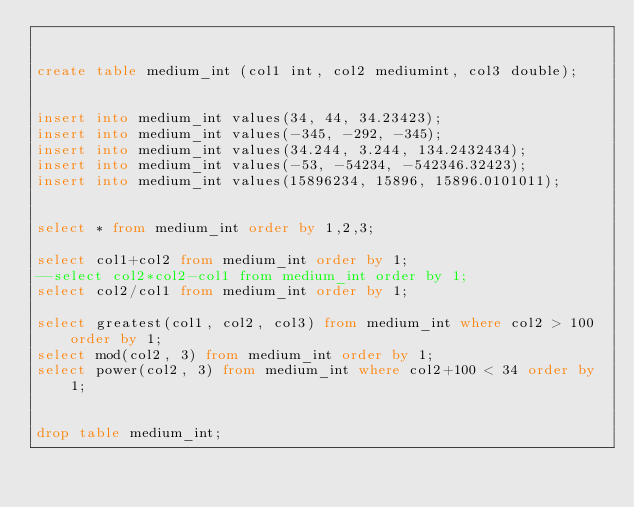<code> <loc_0><loc_0><loc_500><loc_500><_SQL_>

create table medium_int (col1 int, col2 mediumint, col3 double);


insert into medium_int values(34, 44, 34.23423);
insert into medium_int values(-345, -292, -345);
insert into medium_int values(34.244, 3.244, 134.2432434);
insert into medium_int values(-53, -54234, -542346.32423);
insert into medium_int values(15896234, 15896, 15896.0101011);


select * from medium_int order by 1,2,3;

select col1+col2 from medium_int order by 1;
--select col2*col2-col1 from medium_int order by 1;
select col2/col1 from medium_int order by 1;

select greatest(col1, col2, col3) from medium_int where col2 > 100 order by 1;
select mod(col2, 3) from medium_int order by 1;
select power(col2, 3) from medium_int where col2+100 < 34 order by 1;


drop table medium_int;



</code> 